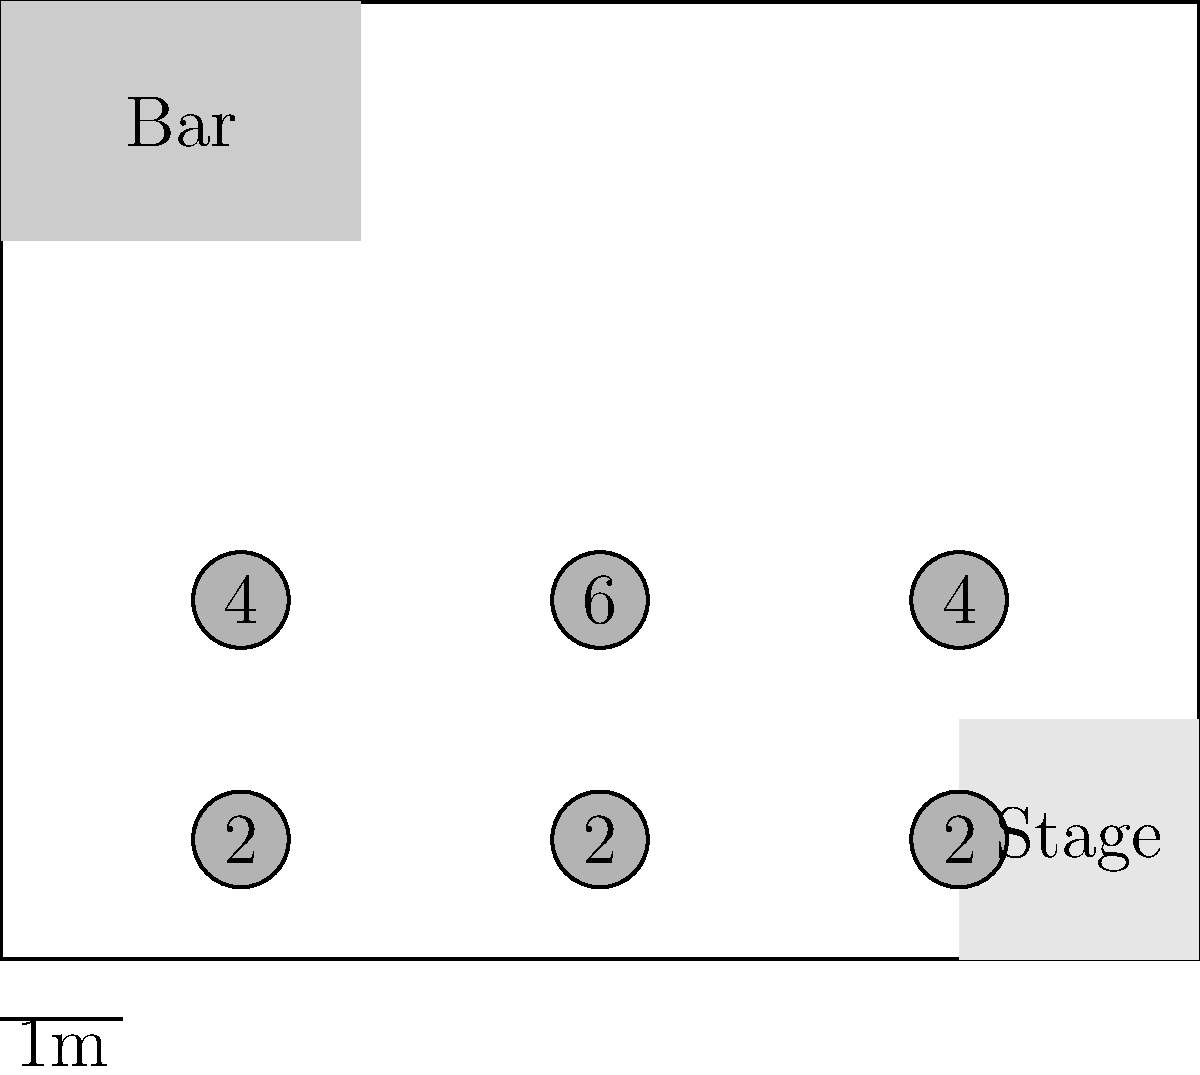Given the pub floor plan above, what is the maximum number of customers that can be seated if social distancing requires a minimum of 2 meters between occupied tables? Assume that partially occupied tables still count as occupied. To solve this problem, we need to follow these steps:

1. Identify the tables that can be occupied while maintaining the 2-meter distance:
   - We can't use adjacent tables, as they are less than 2 meters apart.
   - We need to choose a combination of tables that maximizes occupancy while maintaining distance.

2. Examine possible combinations:
   a) Tables (2,3), (8,1): 4 + 2 = 6 customers
   b) Tables (5,3), (2,1), (8,3): 6 + 2 + 4 = 12 customers
   c) Tables (2,3), (8,3), (5,1): 4 + 4 + 2 = 10 customers

3. Identify the maximum:
   The combination in (b) yields the highest number of customers: 12

Therefore, the maximum number of customers that can be seated while maintaining social distancing is 12.
Answer: 12 customers 